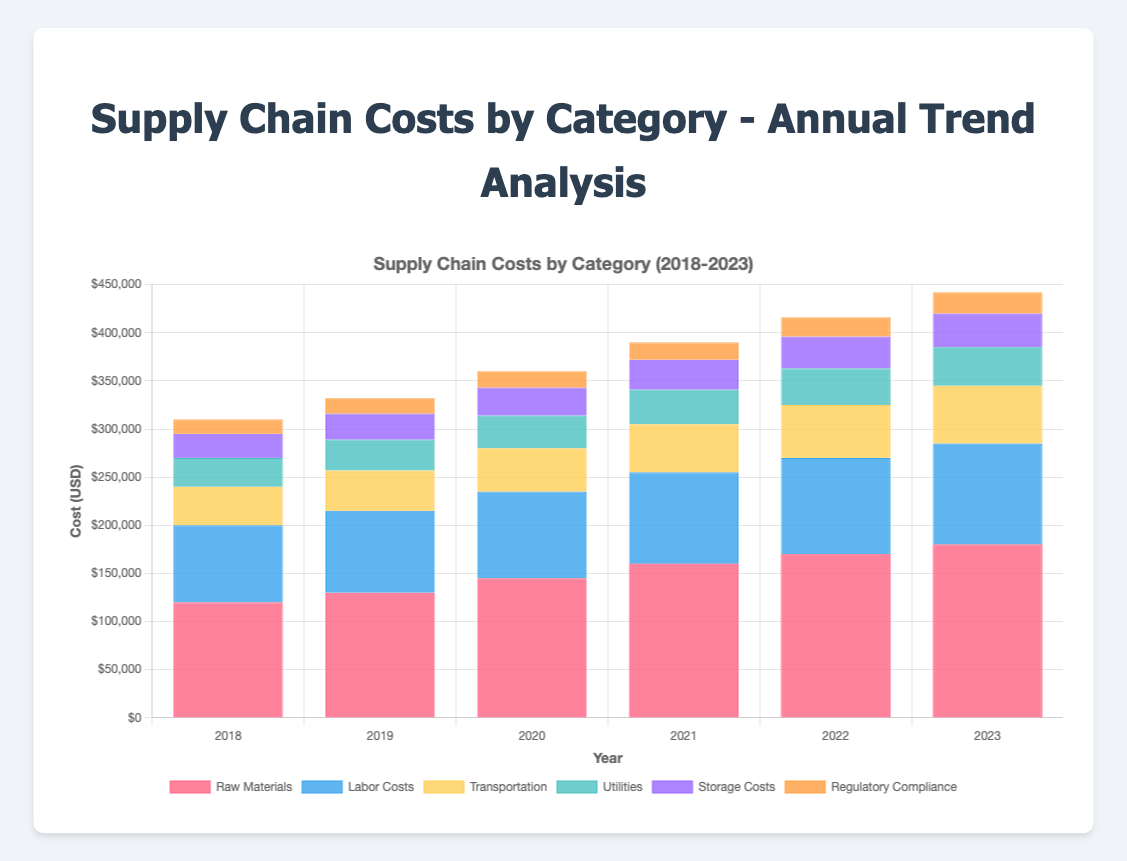What category has seen the highest increase in costs from 2018 to 2023? To determine the category with the highest increase, calculate the difference between the 2023 and 2018 costs for each category: Raw Materials (180000 - 120000 = 60000), Labor Costs (105000 - 80000 = 25000), Transportation (60000 - 40000 = 20000), Utilities (40000 - 30000 = 10000), Storage Costs (35000 - 25000 = 10000), Regulatory Compliance (22000 - 15000 = 7000). The highest increase is in Raw Materials at 60000.
Answer: Raw Materials How do the labor costs in 2019 compare to the transportation costs in 2023? Compare the costs of Labor Costs in 2019 (85000) with Transportation in 2023 (60000). Since 85000 is greater than 60000, labor costs in 2019 are higher.
Answer: Labor Costs in 2019 are greater than Transportation in 2023 What is the total supply chain cost for the year 2022? To find the total cost for 2022, sum all category costs for that year: Raw Materials (170000) + Labor Costs (100000) + Transportation (55000) + Utilities (38000) + Storage Costs (33000) + Regulatory Compliance (20000). This results in 416000.
Answer: 416000 Which year saw the lowest storage costs? Look at the data for Storage Costs across all years: 2018 (25000), 2019 (27000), 2020 (29000), 2021 (31000), 2022 (33000), 2023 (35000). The lowest value is in 2018.
Answer: 2018 What percentage increase in regulatory compliance costs occurred from 2018 to 2023? Calculate the increase from 2018 to 2023: (22000 - 15000 = 7000). Then find the percentage increase: (7000 / 15000) * 100 = 46.67%.
Answer: 46.67% Which category had the most consistent annual cost increase? To find the most consistent annual cost increase, examine the year-to-year increments for each category. Raw Materials (10000, 15000, 15000, 10000, 10000), Labor Costs (5000, 5000, 5000, 5000, 5000), Transportation (2000, 3000, 5000, 5000, 5000), Utilities (2000, 2000, 2000, 2000, 2000), Storage Costs (2000, 2000, 2000, 2000, 2000), Regulatory Compliance (1000, 1000, 1000, 2000, 2000). Utilities and Storage Costs increased evenly by 2000 annually.
Answer: Utilities and Storage Costs By how much did the total cost increase from 2018 to 2023? Calculate the total costs for 2018 and 2023: Total 2018 = 120000 + 80000 + 40000 + 30000 + 25000 + 15000 = 290000. Total 2023 = 180000 + 105000 + 60000 + 40000 + 35000 + 22000 = 442000. The increase is 442000 - 290000 = 152000.
Answer: 152000 In which year did transportation costs surpass the 45000 mark? Review the annual transportation costs: 2018 (40000), 2019 (42000), 2020 (45000), 2021 (50000), 2022 (55000), 2023 (60000). The transportation costs surpass 45000 in 2021.
Answer: 2021 